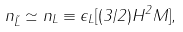<formula> <loc_0><loc_0><loc_500><loc_500>n _ { \tilde { L } } \simeq n _ { L } \equiv \epsilon _ { L } [ ( 3 / 2 ) H ^ { 2 } M ] ,</formula> 